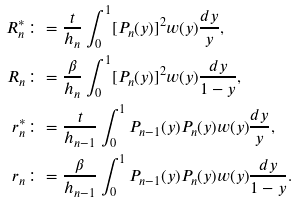<formula> <loc_0><loc_0><loc_500><loc_500>R ^ { * } _ { n } & \colon = \frac { t } { h _ { n } } \int _ { 0 } ^ { 1 } [ P _ { n } ( y ) ] ^ { 2 } w ( y ) \frac { d y } { y } , \\ R _ { n } & \colon = \frac { \beta } { h _ { n } } \int _ { 0 } ^ { 1 } [ P _ { n } ( y ) ] ^ { 2 } w ( y ) \frac { d y } { 1 - y } , \\ r ^ { * } _ { n } & \colon = \frac { t } { h _ { n - 1 } } \int _ { 0 } ^ { 1 } P _ { n - 1 } ( y ) P _ { n } ( y ) w ( y ) \frac { d y } { y } , \\ r _ { n } & \colon = \frac { \beta } { h _ { n - 1 } } \int _ { 0 } ^ { 1 } P _ { n - 1 } ( y ) P _ { n } ( y ) w ( y ) \frac { d y } { 1 - y } .</formula> 